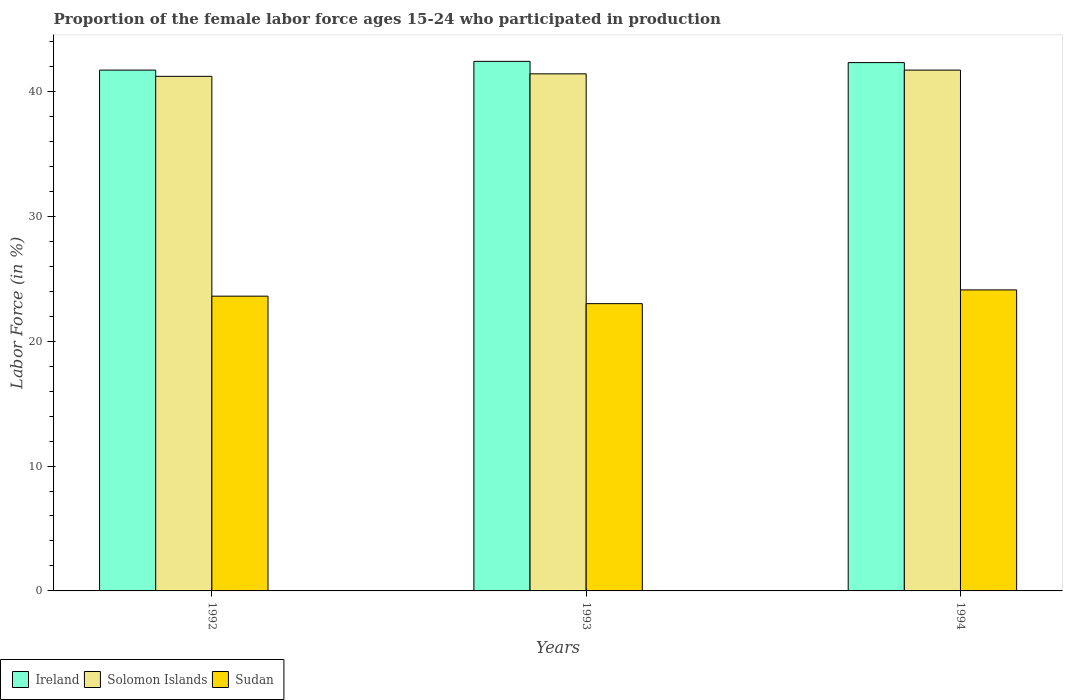How many different coloured bars are there?
Keep it short and to the point. 3. Are the number of bars on each tick of the X-axis equal?
Provide a succinct answer. Yes. What is the label of the 2nd group of bars from the left?
Keep it short and to the point. 1993. In how many cases, is the number of bars for a given year not equal to the number of legend labels?
Make the answer very short. 0. What is the proportion of the female labor force who participated in production in Solomon Islands in 1993?
Make the answer very short. 41.4. Across all years, what is the maximum proportion of the female labor force who participated in production in Solomon Islands?
Keep it short and to the point. 41.7. Across all years, what is the minimum proportion of the female labor force who participated in production in Ireland?
Your answer should be compact. 41.7. What is the total proportion of the female labor force who participated in production in Sudan in the graph?
Your response must be concise. 70.7. What is the difference between the proportion of the female labor force who participated in production in Ireland in 1993 and that in 1994?
Give a very brief answer. 0.1. What is the difference between the proportion of the female labor force who participated in production in Sudan in 1992 and the proportion of the female labor force who participated in production in Solomon Islands in 1994?
Give a very brief answer. -18.1. What is the average proportion of the female labor force who participated in production in Sudan per year?
Your answer should be very brief. 23.57. In the year 1994, what is the difference between the proportion of the female labor force who participated in production in Sudan and proportion of the female labor force who participated in production in Ireland?
Provide a succinct answer. -18.2. What is the ratio of the proportion of the female labor force who participated in production in Ireland in 1992 to that in 1993?
Keep it short and to the point. 0.98. What is the difference between the highest and the lowest proportion of the female labor force who participated in production in Sudan?
Make the answer very short. 1.1. What does the 1st bar from the left in 1994 represents?
Keep it short and to the point. Ireland. What does the 3rd bar from the right in 1992 represents?
Give a very brief answer. Ireland. How many bars are there?
Offer a very short reply. 9. Are all the bars in the graph horizontal?
Keep it short and to the point. No. How many years are there in the graph?
Offer a terse response. 3. What is the difference between two consecutive major ticks on the Y-axis?
Make the answer very short. 10. Are the values on the major ticks of Y-axis written in scientific E-notation?
Make the answer very short. No. How many legend labels are there?
Offer a terse response. 3. What is the title of the graph?
Ensure brevity in your answer.  Proportion of the female labor force ages 15-24 who participated in production. What is the label or title of the Y-axis?
Offer a terse response. Labor Force (in %). What is the Labor Force (in %) of Ireland in 1992?
Offer a very short reply. 41.7. What is the Labor Force (in %) in Solomon Islands in 1992?
Ensure brevity in your answer.  41.2. What is the Labor Force (in %) of Sudan in 1992?
Offer a terse response. 23.6. What is the Labor Force (in %) of Ireland in 1993?
Make the answer very short. 42.4. What is the Labor Force (in %) of Solomon Islands in 1993?
Your response must be concise. 41.4. What is the Labor Force (in %) in Ireland in 1994?
Offer a terse response. 42.3. What is the Labor Force (in %) of Solomon Islands in 1994?
Give a very brief answer. 41.7. What is the Labor Force (in %) of Sudan in 1994?
Give a very brief answer. 24.1. Across all years, what is the maximum Labor Force (in %) of Ireland?
Provide a succinct answer. 42.4. Across all years, what is the maximum Labor Force (in %) of Solomon Islands?
Offer a terse response. 41.7. Across all years, what is the maximum Labor Force (in %) of Sudan?
Your answer should be compact. 24.1. Across all years, what is the minimum Labor Force (in %) of Ireland?
Your answer should be very brief. 41.7. Across all years, what is the minimum Labor Force (in %) in Solomon Islands?
Give a very brief answer. 41.2. Across all years, what is the minimum Labor Force (in %) in Sudan?
Provide a short and direct response. 23. What is the total Labor Force (in %) in Ireland in the graph?
Offer a terse response. 126.4. What is the total Labor Force (in %) of Solomon Islands in the graph?
Provide a short and direct response. 124.3. What is the total Labor Force (in %) of Sudan in the graph?
Make the answer very short. 70.7. What is the difference between the Labor Force (in %) of Solomon Islands in 1992 and that in 1993?
Offer a very short reply. -0.2. What is the difference between the Labor Force (in %) in Solomon Islands in 1992 and that in 1994?
Keep it short and to the point. -0.5. What is the difference between the Labor Force (in %) of Solomon Islands in 1993 and that in 1994?
Your answer should be compact. -0.3. What is the difference between the Labor Force (in %) in Ireland in 1992 and the Labor Force (in %) in Solomon Islands in 1994?
Ensure brevity in your answer.  0. What is the difference between the Labor Force (in %) of Ireland in 1992 and the Labor Force (in %) of Sudan in 1994?
Provide a short and direct response. 17.6. What is the difference between the Labor Force (in %) in Ireland in 1993 and the Labor Force (in %) in Sudan in 1994?
Give a very brief answer. 18.3. What is the difference between the Labor Force (in %) of Solomon Islands in 1993 and the Labor Force (in %) of Sudan in 1994?
Ensure brevity in your answer.  17.3. What is the average Labor Force (in %) in Ireland per year?
Your answer should be compact. 42.13. What is the average Labor Force (in %) of Solomon Islands per year?
Offer a terse response. 41.43. What is the average Labor Force (in %) of Sudan per year?
Provide a succinct answer. 23.57. In the year 1992, what is the difference between the Labor Force (in %) in Ireland and Labor Force (in %) in Solomon Islands?
Your response must be concise. 0.5. In the year 1992, what is the difference between the Labor Force (in %) of Ireland and Labor Force (in %) of Sudan?
Make the answer very short. 18.1. In the year 1993, what is the difference between the Labor Force (in %) in Ireland and Labor Force (in %) in Solomon Islands?
Your answer should be very brief. 1. In the year 1993, what is the difference between the Labor Force (in %) of Ireland and Labor Force (in %) of Sudan?
Provide a succinct answer. 19.4. In the year 1993, what is the difference between the Labor Force (in %) of Solomon Islands and Labor Force (in %) of Sudan?
Offer a very short reply. 18.4. In the year 1994, what is the difference between the Labor Force (in %) of Ireland and Labor Force (in %) of Solomon Islands?
Your answer should be compact. 0.6. In the year 1994, what is the difference between the Labor Force (in %) of Ireland and Labor Force (in %) of Sudan?
Your answer should be very brief. 18.2. In the year 1994, what is the difference between the Labor Force (in %) in Solomon Islands and Labor Force (in %) in Sudan?
Make the answer very short. 17.6. What is the ratio of the Labor Force (in %) of Ireland in 1992 to that in 1993?
Your answer should be compact. 0.98. What is the ratio of the Labor Force (in %) in Sudan in 1992 to that in 1993?
Provide a short and direct response. 1.03. What is the ratio of the Labor Force (in %) of Ireland in 1992 to that in 1994?
Keep it short and to the point. 0.99. What is the ratio of the Labor Force (in %) of Sudan in 1992 to that in 1994?
Offer a terse response. 0.98. What is the ratio of the Labor Force (in %) in Ireland in 1993 to that in 1994?
Provide a short and direct response. 1. What is the ratio of the Labor Force (in %) of Solomon Islands in 1993 to that in 1994?
Keep it short and to the point. 0.99. What is the ratio of the Labor Force (in %) in Sudan in 1993 to that in 1994?
Offer a terse response. 0.95. What is the difference between the highest and the second highest Labor Force (in %) in Solomon Islands?
Your response must be concise. 0.3. What is the difference between the highest and the second highest Labor Force (in %) in Sudan?
Keep it short and to the point. 0.5. What is the difference between the highest and the lowest Labor Force (in %) in Solomon Islands?
Offer a terse response. 0.5. 